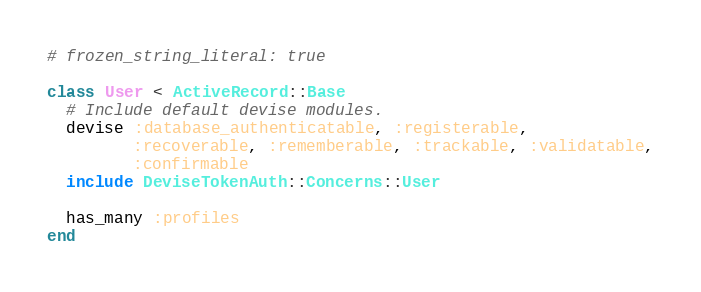Convert code to text. <code><loc_0><loc_0><loc_500><loc_500><_Ruby_># frozen_string_literal: true

class User < ActiveRecord::Base
  # Include default devise modules.
  devise :database_authenticatable, :registerable,
         :recoverable, :rememberable, :trackable, :validatable,
         :confirmable
  include DeviseTokenAuth::Concerns::User

  has_many :profiles
end
</code> 